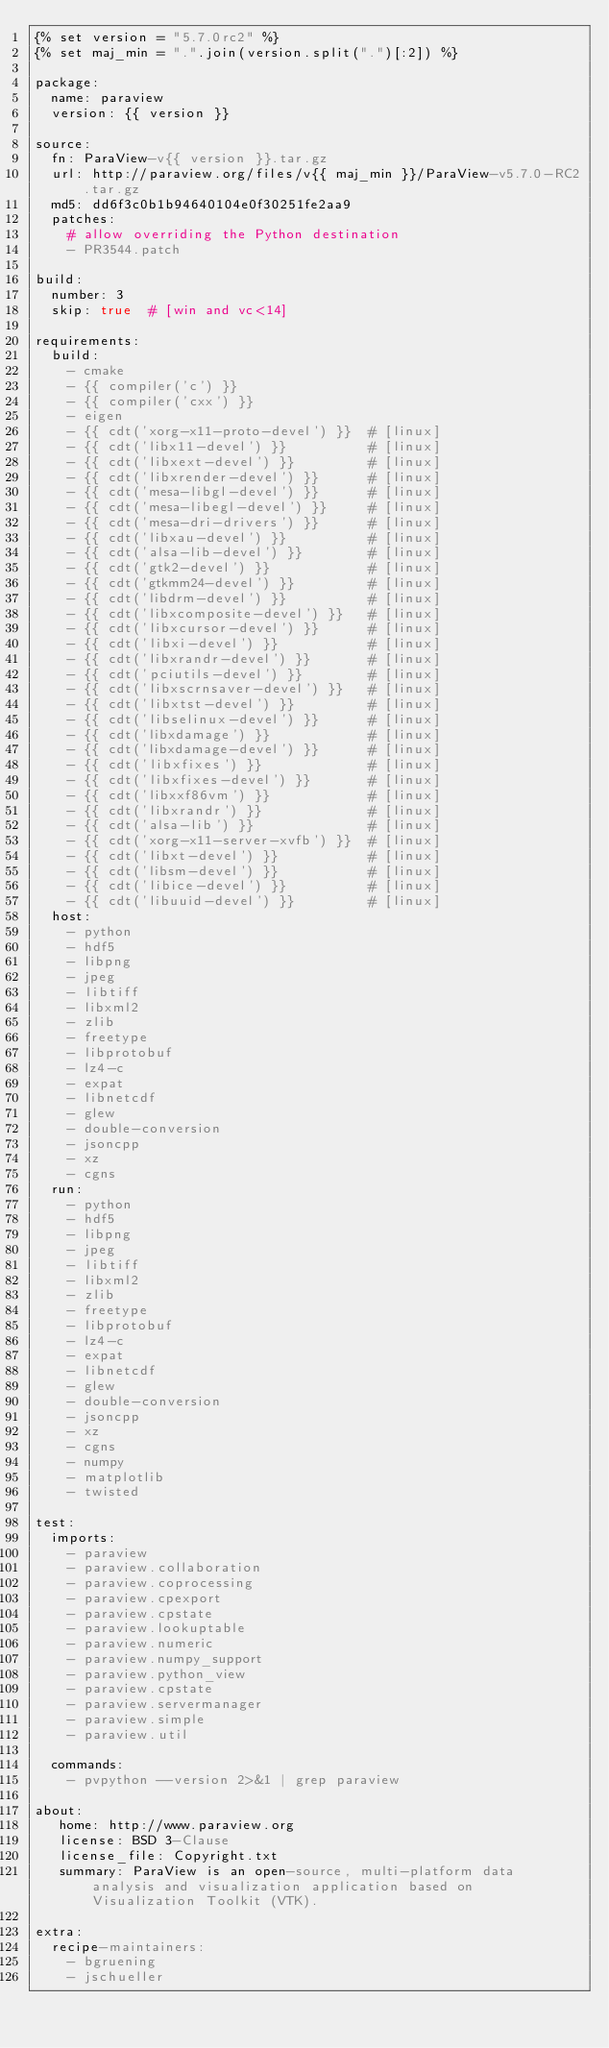Convert code to text. <code><loc_0><loc_0><loc_500><loc_500><_YAML_>{% set version = "5.7.0rc2" %}
{% set maj_min = ".".join(version.split(".")[:2]) %}

package:
  name: paraview
  version: {{ version }}

source:
  fn: ParaView-v{{ version }}.tar.gz
  url: http://paraview.org/files/v{{ maj_min }}/ParaView-v5.7.0-RC2.tar.gz
  md5: dd6f3c0b1b94640104e0f30251fe2aa9
  patches:
    # allow overriding the Python destination
    - PR3544.patch

build:
  number: 3
  skip: true  # [win and vc<14]

requirements:
  build:
    - cmake
    - {{ compiler('c') }}
    - {{ compiler('cxx') }}
    - eigen
    - {{ cdt('xorg-x11-proto-devel') }}  # [linux]
    - {{ cdt('libx11-devel') }}          # [linux]
    - {{ cdt('libxext-devel') }}         # [linux]
    - {{ cdt('libxrender-devel') }}      # [linux]
    - {{ cdt('mesa-libgl-devel') }}      # [linux]
    - {{ cdt('mesa-libegl-devel') }}     # [linux]
    - {{ cdt('mesa-dri-drivers') }}      # [linux]
    - {{ cdt('libxau-devel') }}          # [linux]
    - {{ cdt('alsa-lib-devel') }}        # [linux]
    - {{ cdt('gtk2-devel') }}            # [linux]
    - {{ cdt('gtkmm24-devel') }}         # [linux]
    - {{ cdt('libdrm-devel') }}          # [linux]
    - {{ cdt('libxcomposite-devel') }}   # [linux]
    - {{ cdt('libxcursor-devel') }}      # [linux]
    - {{ cdt('libxi-devel') }}           # [linux]
    - {{ cdt('libxrandr-devel') }}       # [linux]
    - {{ cdt('pciutils-devel') }}        # [linux]
    - {{ cdt('libxscrnsaver-devel') }}   # [linux]
    - {{ cdt('libxtst-devel') }}         # [linux]
    - {{ cdt('libselinux-devel') }}      # [linux]
    - {{ cdt('libxdamage') }}            # [linux]
    - {{ cdt('libxdamage-devel') }}      # [linux]
    - {{ cdt('libxfixes') }}             # [linux]
    - {{ cdt('libxfixes-devel') }}       # [linux]
    - {{ cdt('libxxf86vm') }}            # [linux]
    - {{ cdt('libxrandr') }}             # [linux]
    - {{ cdt('alsa-lib') }}              # [linux]
    - {{ cdt('xorg-x11-server-xvfb') }}  # [linux]
    - {{ cdt('libxt-devel') }}           # [linux]
    - {{ cdt('libsm-devel') }}           # [linux]
    - {{ cdt('libice-devel') }}          # [linux]
    - {{ cdt('libuuid-devel') }}         # [linux]
  host:
    - python
    - hdf5
    - libpng
    - jpeg
    - libtiff
    - libxml2
    - zlib
    - freetype
    - libprotobuf
    - lz4-c
    - expat
    - libnetcdf
    - glew
    - double-conversion
    - jsoncpp
    - xz
    - cgns
  run:
    - python
    - hdf5
    - libpng
    - jpeg
    - libtiff
    - libxml2
    - zlib
    - freetype
    - libprotobuf
    - lz4-c
    - expat
    - libnetcdf
    - glew
    - double-conversion
    - jsoncpp
    - xz
    - cgns
    - numpy
    - matplotlib
    - twisted

test:
  imports:
    - paraview
    - paraview.collaboration
    - paraview.coprocessing
    - paraview.cpexport
    - paraview.cpstate
    - paraview.lookuptable
    - paraview.numeric
    - paraview.numpy_support
    - paraview.python_view
    - paraview.cpstate
    - paraview.servermanager
    - paraview.simple
    - paraview.util

  commands:
    - pvpython --version 2>&1 | grep paraview

about:
   home: http://www.paraview.org
   license: BSD 3-Clause
   license_file: Copyright.txt
   summary: ParaView is an open-source, multi-platform data analysis and visualization application based on Visualization Toolkit (VTK).

extra:
  recipe-maintainers:
    - bgruening
    - jschueller
</code> 